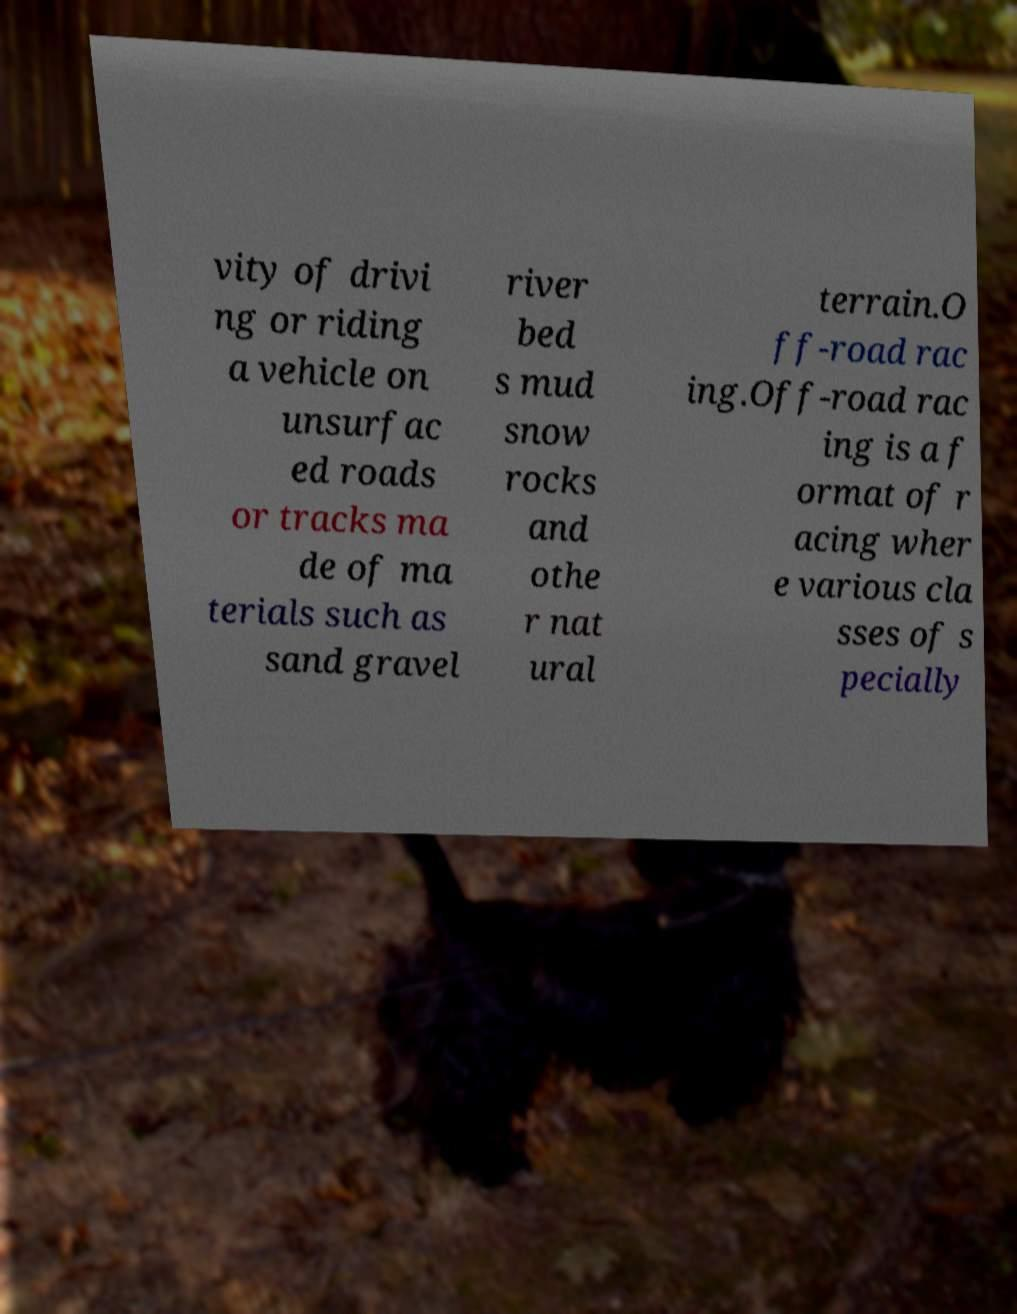Please read and relay the text visible in this image. What does it say? vity of drivi ng or riding a vehicle on unsurfac ed roads or tracks ma de of ma terials such as sand gravel river bed s mud snow rocks and othe r nat ural terrain.O ff-road rac ing.Off-road rac ing is a f ormat of r acing wher e various cla sses of s pecially 